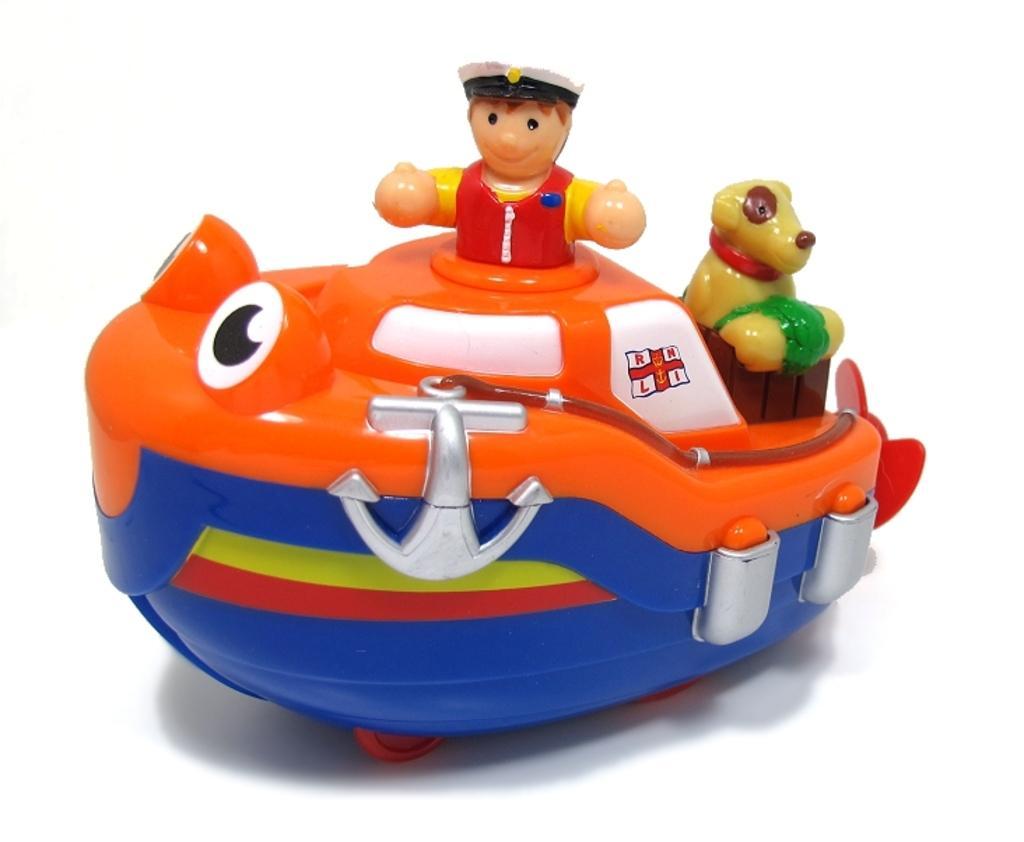Please provide a concise description of this image. Here we can see toy. 